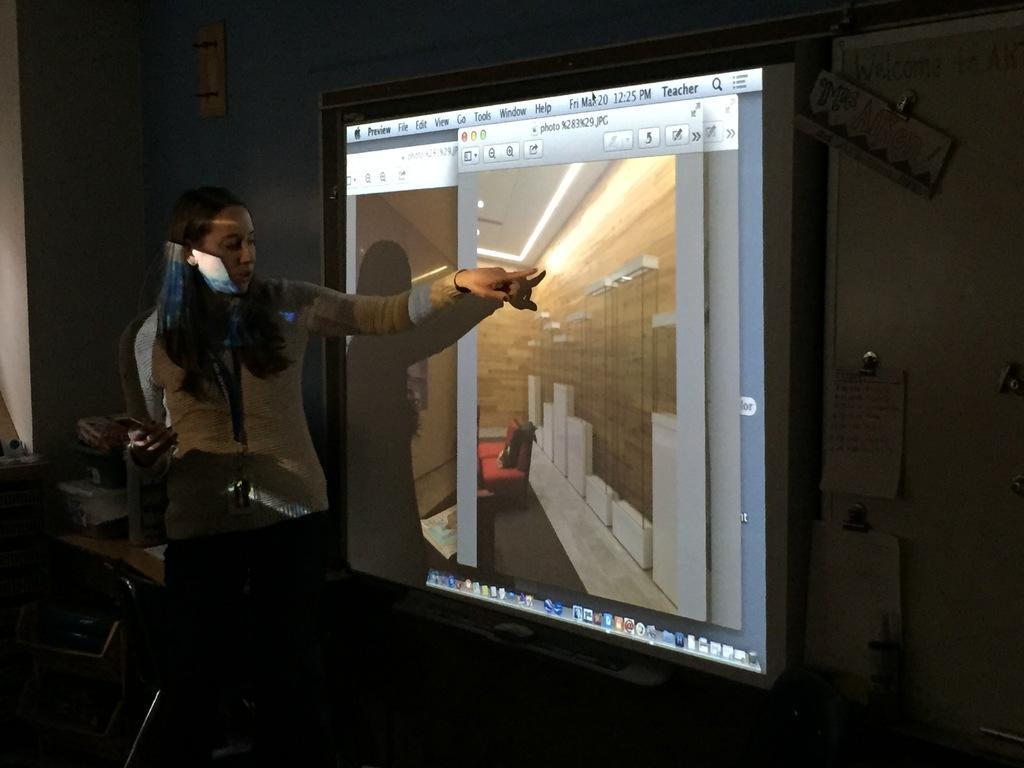In one or two sentences, can you explain what this image depicts? In this image I can see a person standing wearing cream color jacket, in front I can see a projector screen and I can see dark background. 